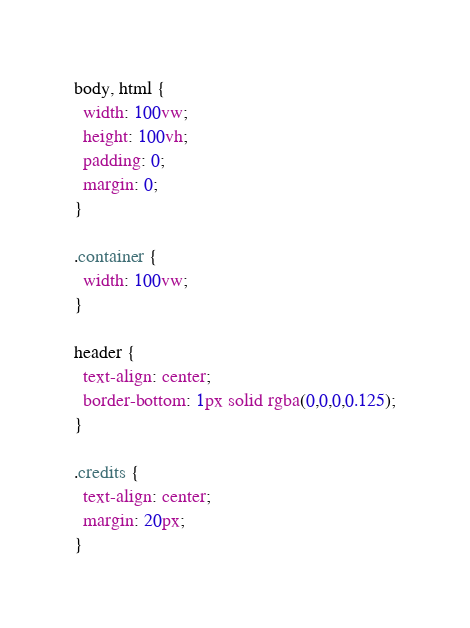Convert code to text. <code><loc_0><loc_0><loc_500><loc_500><_CSS_>body, html {
  width: 100vw;
  height: 100vh;
  padding: 0;
  margin: 0;
}

.container {
  width: 100vw;
}

header {
  text-align: center;
  border-bottom: 1px solid rgba(0,0,0,0.125);
}

.credits {
  text-align: center;
  margin: 20px;
}
</code> 